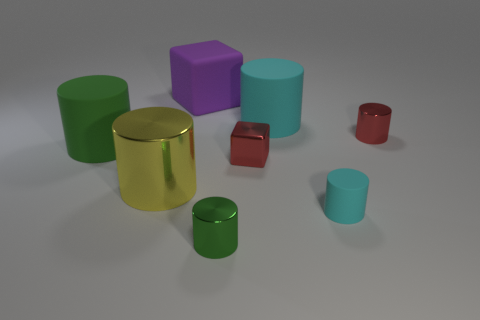How many green cylinders must be subtracted to get 1 green cylinders? 1 Subtract all red metallic cylinders. How many cylinders are left? 5 Add 1 gray cubes. How many objects exist? 9 Subtract all yellow cylinders. How many cylinders are left? 5 Subtract all green balls. How many red blocks are left? 1 Add 7 red shiny blocks. How many red shiny blocks exist? 8 Subtract 0 gray blocks. How many objects are left? 8 Subtract all cylinders. How many objects are left? 2 Subtract 1 cylinders. How many cylinders are left? 5 Subtract all blue cylinders. Subtract all gray blocks. How many cylinders are left? 6 